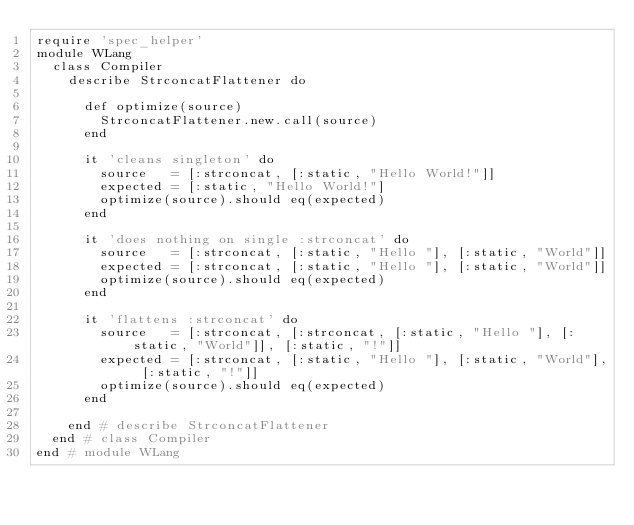Convert code to text. <code><loc_0><loc_0><loc_500><loc_500><_Ruby_>require 'spec_helper'
module WLang
  class Compiler
    describe StrconcatFlattener do

      def optimize(source)
        StrconcatFlattener.new.call(source)
      end

      it 'cleans singleton' do
        source   = [:strconcat, [:static, "Hello World!"]]
        expected = [:static, "Hello World!"]
        optimize(source).should eq(expected)
      end

      it 'does nothing on single :strconcat' do
        source   = [:strconcat, [:static, "Hello "], [:static, "World"]]
        expected = [:strconcat, [:static, "Hello "], [:static, "World"]]
        optimize(source).should eq(expected)
      end

      it 'flattens :strconcat' do
        source   = [:strconcat, [:strconcat, [:static, "Hello "], [:static, "World"]], [:static, "!"]]
        expected = [:strconcat, [:static, "Hello "], [:static, "World"], [:static, "!"]]
        optimize(source).should eq(expected)
      end

    end # describe StrconcatFlattener
  end # class Compiler
end # module WLang
</code> 